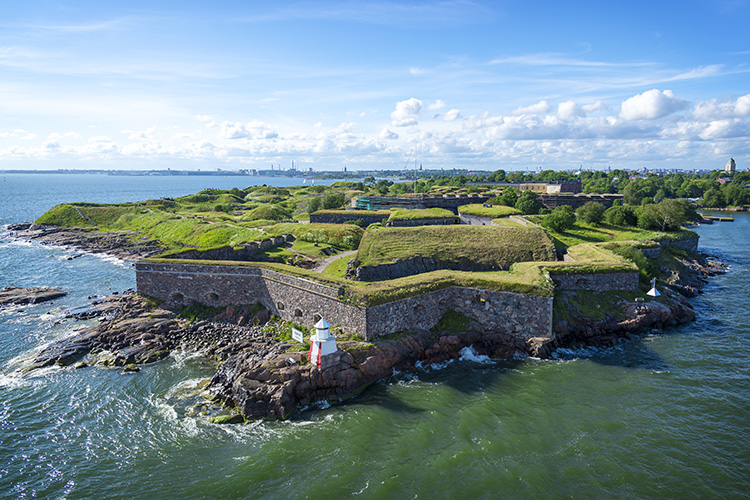What are the key elements in this picture? The image provides a stunning aerial view of the Suomenlinna Fortress, a significant historical landmark and UNESCO World Heritage Site located in Helsinki, Finland. Key elements in the picture include:

1. **Fortress Walls:** The robust, stone-built walls of the fortress, covered in lush green grass, dominate the landscape. These walls reflect the architectural ingenuity of historical construction methods.

2. **Natural Surroundings:** The green grass and natural foliage blend seamlessly with the constructed elements, creating an intertwined scene of nature and history.

3. **Water Surroundings:** The vast body of water surrounding the fortress is calm and serene, further enhancing the natural beauty and tranquility of the scene. The water also acts as a reflective surface for the clear blue sky.

4. **Sky and Clouds:** The clear blue sky and scattered clouds add depth and expansiveness to the image, creating a picturesque backdrop.

5. **Cityscape:** In the distance, the city of Helsinki with its modern architecture contrasts with the historical elements of the fortress, signifying the blend of old and new.

Overall, the image captures the fortress's majestic presence amid natural beauty and urban modernity, highlighting its historical and cultural significance. 